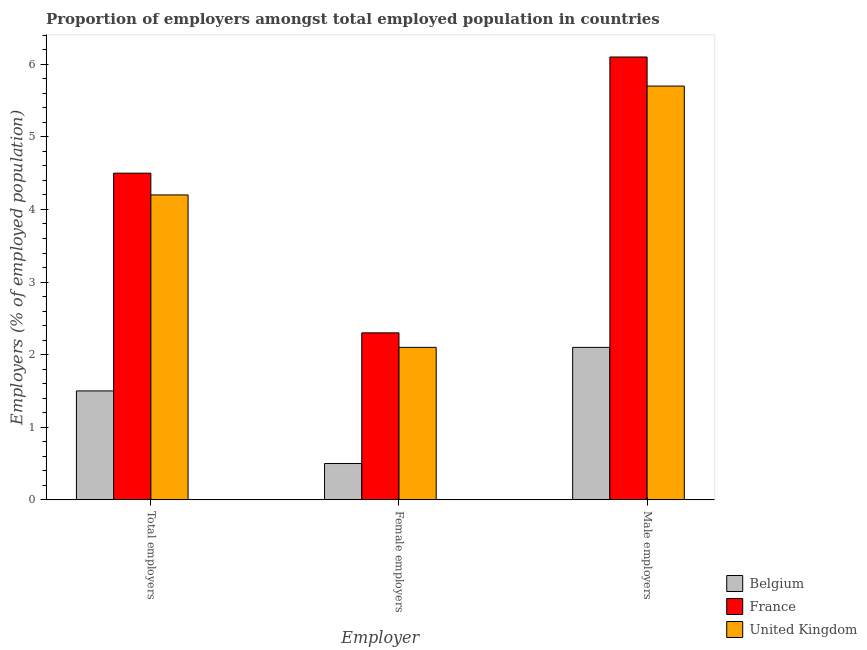How many groups of bars are there?
Your answer should be compact. 3. Are the number of bars per tick equal to the number of legend labels?
Give a very brief answer. Yes. How many bars are there on the 3rd tick from the left?
Offer a terse response. 3. How many bars are there on the 1st tick from the right?
Your answer should be compact. 3. What is the label of the 1st group of bars from the left?
Provide a succinct answer. Total employers. What is the percentage of male employers in Belgium?
Offer a terse response. 2.1. Across all countries, what is the maximum percentage of total employers?
Your response must be concise. 4.5. What is the total percentage of total employers in the graph?
Make the answer very short. 10.2. What is the difference between the percentage of total employers in Belgium and that in France?
Your answer should be very brief. -3. What is the difference between the percentage of female employers in United Kingdom and the percentage of male employers in France?
Give a very brief answer. -4. What is the average percentage of female employers per country?
Your answer should be very brief. 1.63. What is the difference between the percentage of total employers and percentage of female employers in France?
Offer a very short reply. 2.2. What is the ratio of the percentage of female employers in Belgium to that in United Kingdom?
Offer a terse response. 0.24. Is the difference between the percentage of female employers in France and United Kingdom greater than the difference between the percentage of male employers in France and United Kingdom?
Give a very brief answer. No. What is the difference between the highest and the second highest percentage of total employers?
Offer a terse response. 0.3. What is the difference between the highest and the lowest percentage of total employers?
Keep it short and to the point. 3. Is it the case that in every country, the sum of the percentage of total employers and percentage of female employers is greater than the percentage of male employers?
Offer a very short reply. No. How many countries are there in the graph?
Offer a terse response. 3. Does the graph contain any zero values?
Your answer should be very brief. No. Does the graph contain grids?
Your answer should be compact. No. What is the title of the graph?
Give a very brief answer. Proportion of employers amongst total employed population in countries. What is the label or title of the X-axis?
Make the answer very short. Employer. What is the label or title of the Y-axis?
Provide a short and direct response. Employers (% of employed population). What is the Employers (% of employed population) in Belgium in Total employers?
Give a very brief answer. 1.5. What is the Employers (% of employed population) of United Kingdom in Total employers?
Your answer should be compact. 4.2. What is the Employers (% of employed population) in Belgium in Female employers?
Give a very brief answer. 0.5. What is the Employers (% of employed population) in France in Female employers?
Ensure brevity in your answer.  2.3. What is the Employers (% of employed population) in United Kingdom in Female employers?
Your answer should be very brief. 2.1. What is the Employers (% of employed population) of Belgium in Male employers?
Provide a short and direct response. 2.1. What is the Employers (% of employed population) in France in Male employers?
Make the answer very short. 6.1. What is the Employers (% of employed population) in United Kingdom in Male employers?
Provide a succinct answer. 5.7. Across all Employer, what is the maximum Employers (% of employed population) of Belgium?
Ensure brevity in your answer.  2.1. Across all Employer, what is the maximum Employers (% of employed population) of France?
Your response must be concise. 6.1. Across all Employer, what is the maximum Employers (% of employed population) of United Kingdom?
Keep it short and to the point. 5.7. Across all Employer, what is the minimum Employers (% of employed population) of France?
Your response must be concise. 2.3. Across all Employer, what is the minimum Employers (% of employed population) in United Kingdom?
Ensure brevity in your answer.  2.1. What is the total Employers (% of employed population) in United Kingdom in the graph?
Make the answer very short. 12. What is the difference between the Employers (% of employed population) in United Kingdom in Total employers and that in Female employers?
Offer a terse response. 2.1. What is the difference between the Employers (% of employed population) in Belgium in Total employers and that in Male employers?
Keep it short and to the point. -0.6. What is the difference between the Employers (% of employed population) in France in Total employers and that in Male employers?
Your answer should be compact. -1.6. What is the difference between the Employers (% of employed population) in France in Female employers and that in Male employers?
Give a very brief answer. -3.8. What is the difference between the Employers (% of employed population) of Belgium in Total employers and the Employers (% of employed population) of France in Female employers?
Your answer should be very brief. -0.8. What is the difference between the Employers (% of employed population) of Belgium in Total employers and the Employers (% of employed population) of France in Male employers?
Provide a short and direct response. -4.6. What is the difference between the Employers (% of employed population) of France in Total employers and the Employers (% of employed population) of United Kingdom in Male employers?
Give a very brief answer. -1.2. What is the difference between the Employers (% of employed population) in Belgium in Female employers and the Employers (% of employed population) in France in Male employers?
Your response must be concise. -5.6. What is the difference between the Employers (% of employed population) of Belgium in Female employers and the Employers (% of employed population) of United Kingdom in Male employers?
Give a very brief answer. -5.2. What is the average Employers (% of employed population) of Belgium per Employer?
Ensure brevity in your answer.  1.37. What is the average Employers (% of employed population) in France per Employer?
Provide a short and direct response. 4.3. What is the difference between the Employers (% of employed population) in Belgium and Employers (% of employed population) in France in Total employers?
Your response must be concise. -3. What is the difference between the Employers (% of employed population) of Belgium and Employers (% of employed population) of United Kingdom in Total employers?
Offer a terse response. -2.7. What is the difference between the Employers (% of employed population) of France and Employers (% of employed population) of United Kingdom in Total employers?
Keep it short and to the point. 0.3. What is the difference between the Employers (% of employed population) in Belgium and Employers (% of employed population) in France in Female employers?
Offer a terse response. -1.8. What is the difference between the Employers (% of employed population) in France and Employers (% of employed population) in United Kingdom in Female employers?
Your answer should be very brief. 0.2. What is the difference between the Employers (% of employed population) of Belgium and Employers (% of employed population) of France in Male employers?
Give a very brief answer. -4. What is the difference between the Employers (% of employed population) in Belgium and Employers (% of employed population) in United Kingdom in Male employers?
Offer a terse response. -3.6. What is the ratio of the Employers (% of employed population) of Belgium in Total employers to that in Female employers?
Ensure brevity in your answer.  3. What is the ratio of the Employers (% of employed population) of France in Total employers to that in Female employers?
Keep it short and to the point. 1.96. What is the ratio of the Employers (% of employed population) of United Kingdom in Total employers to that in Female employers?
Your response must be concise. 2. What is the ratio of the Employers (% of employed population) of Belgium in Total employers to that in Male employers?
Provide a short and direct response. 0.71. What is the ratio of the Employers (% of employed population) of France in Total employers to that in Male employers?
Your response must be concise. 0.74. What is the ratio of the Employers (% of employed population) in United Kingdom in Total employers to that in Male employers?
Provide a short and direct response. 0.74. What is the ratio of the Employers (% of employed population) in Belgium in Female employers to that in Male employers?
Give a very brief answer. 0.24. What is the ratio of the Employers (% of employed population) of France in Female employers to that in Male employers?
Keep it short and to the point. 0.38. What is the ratio of the Employers (% of employed population) in United Kingdom in Female employers to that in Male employers?
Your answer should be very brief. 0.37. What is the difference between the highest and the second highest Employers (% of employed population) in United Kingdom?
Offer a terse response. 1.5. What is the difference between the highest and the lowest Employers (% of employed population) of Belgium?
Keep it short and to the point. 1.6. 